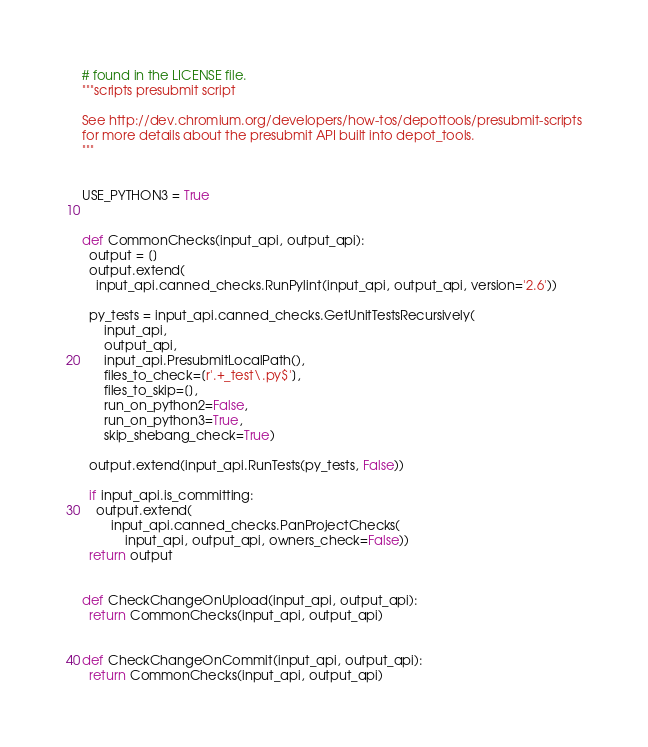Convert code to text. <code><loc_0><loc_0><loc_500><loc_500><_Python_># found in the LICENSE file.
"""scripts presubmit script

See http://dev.chromium.org/developers/how-tos/depottools/presubmit-scripts
for more details about the presubmit API built into depot_tools.
"""


USE_PYTHON3 = True


def CommonChecks(input_api, output_api):
  output = []
  output.extend(
    input_api.canned_checks.RunPylint(input_api, output_api, version='2.6'))

  py_tests = input_api.canned_checks.GetUnitTestsRecursively(
      input_api,
      output_api,
      input_api.PresubmitLocalPath(),
      files_to_check=[r'.+_test\.py$'],
      files_to_skip=[],
      run_on_python2=False,
      run_on_python3=True,
      skip_shebang_check=True)

  output.extend(input_api.RunTests(py_tests, False))

  if input_api.is_committing:
    output.extend(
        input_api.canned_checks.PanProjectChecks(
            input_api, output_api, owners_check=False))
  return output


def CheckChangeOnUpload(input_api, output_api):
  return CommonChecks(input_api, output_api)


def CheckChangeOnCommit(input_api, output_api):
  return CommonChecks(input_api, output_api)
</code> 